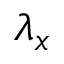Convert formula to latex. <formula><loc_0><loc_0><loc_500><loc_500>\lambda _ { x }</formula> 